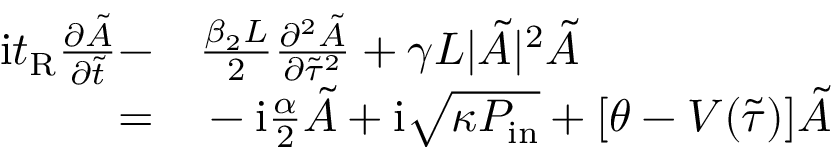<formula> <loc_0><loc_0><loc_500><loc_500>\begin{array} { r l } { i t _ { R } \frac { \partial \tilde { A } } { \partial \tilde { t } } - } & \frac { \beta _ { 2 } L } { 2 } \frac { \partial ^ { 2 } \tilde { A } } { \partial \tilde { \tau } ^ { 2 } } + \gamma L | \tilde { A } | ^ { 2 } \tilde { A } } \\ { = } & - i \frac { \alpha } { 2 } \tilde { A } + i \sqrt { \kappa P _ { i n } } + [ \theta - V ( \tilde { \tau } ) ] \tilde { A } } \end{array}</formula> 